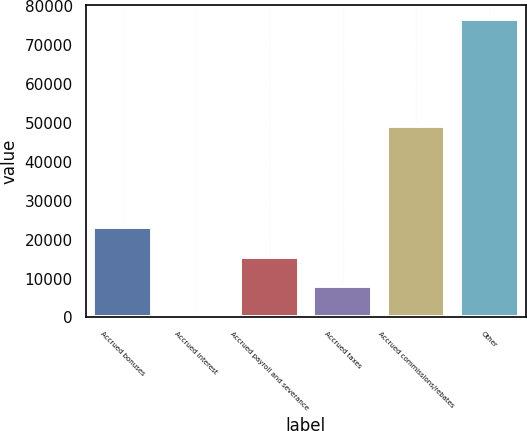Convert chart. <chart><loc_0><loc_0><loc_500><loc_500><bar_chart><fcel>Accrued bonuses<fcel>Accrued interest<fcel>Accrued payroll and severance<fcel>Accrued taxes<fcel>Accrued commissions/rebates<fcel>Other<nl><fcel>23293.9<fcel>433<fcel>15673.6<fcel>8053.3<fcel>49157<fcel>76636<nl></chart> 